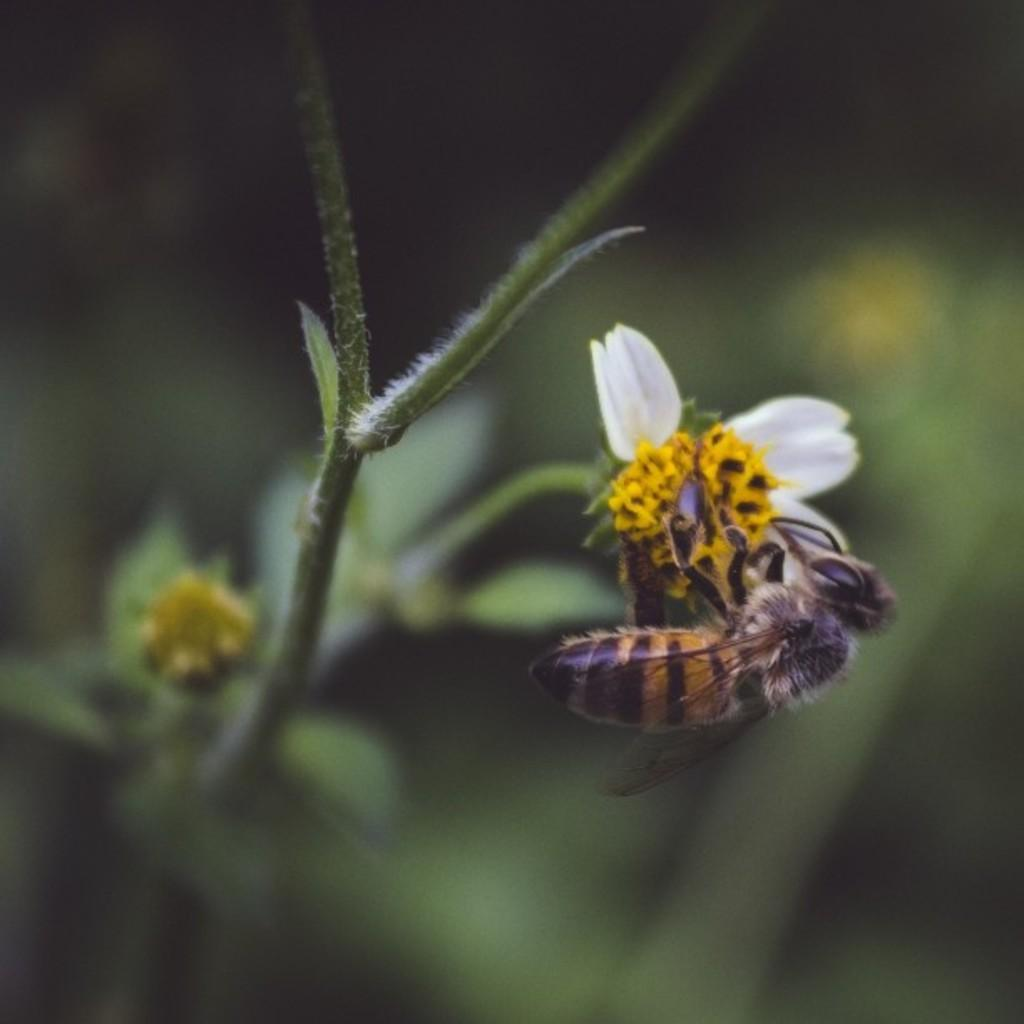What type of insect can be seen in the image? There is a honey bee visible on a flower in the image. What is the honey bee interacting with in the image? The honey bee is interacting with a flower in the image. What can be seen in the middle of the image? There is a stem of a tree in the middle of the image. Can you see the person's feet in the image? There are no feet visible in the image, as it features a honey bee on a flower and a stem of a tree. Is there a toothbrush present in the image? There is no toothbrush present in the image. 